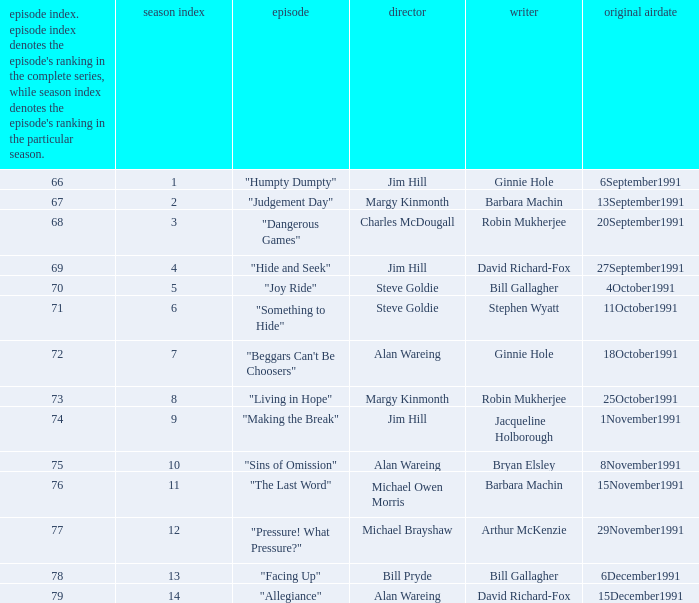Name the least series number for episode number being 78 13.0. 